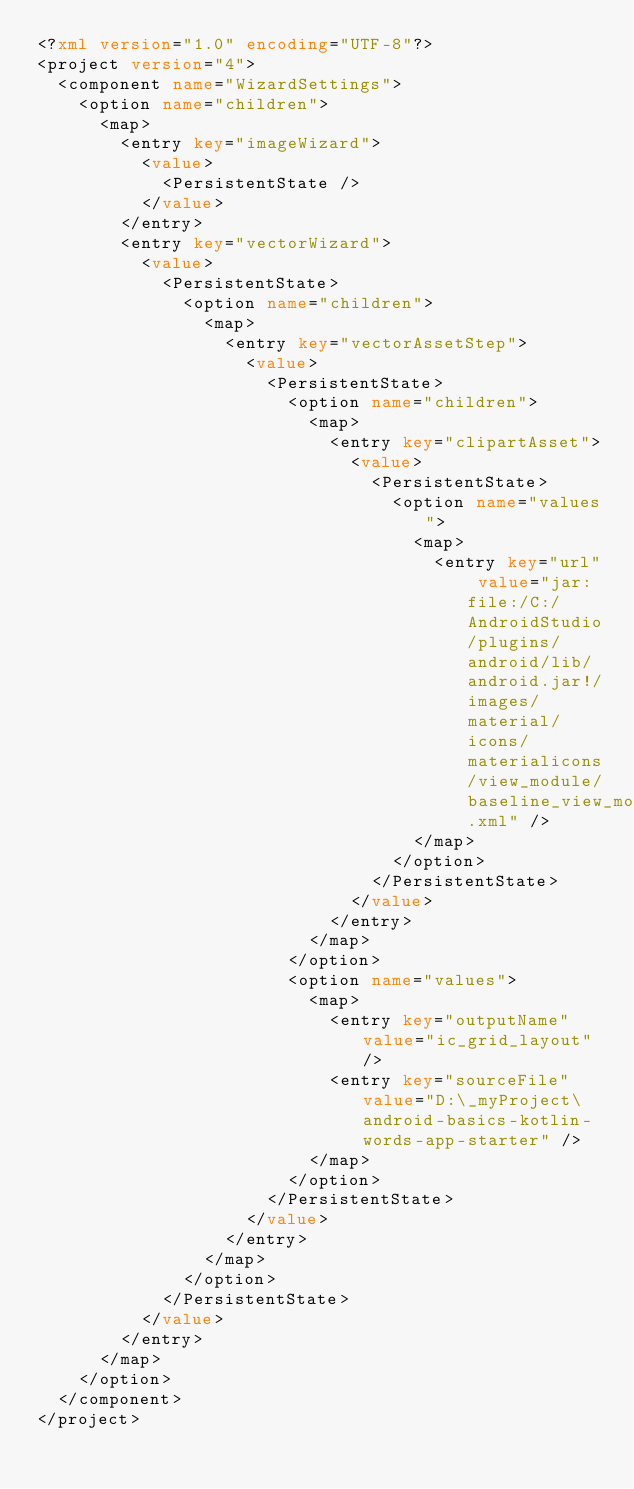Convert code to text. <code><loc_0><loc_0><loc_500><loc_500><_XML_><?xml version="1.0" encoding="UTF-8"?>
<project version="4">
  <component name="WizardSettings">
    <option name="children">
      <map>
        <entry key="imageWizard">
          <value>
            <PersistentState />
          </value>
        </entry>
        <entry key="vectorWizard">
          <value>
            <PersistentState>
              <option name="children">
                <map>
                  <entry key="vectorAssetStep">
                    <value>
                      <PersistentState>
                        <option name="children">
                          <map>
                            <entry key="clipartAsset">
                              <value>
                                <PersistentState>
                                  <option name="values">
                                    <map>
                                      <entry key="url" value="jar:file:/C:/AndroidStudio/plugins/android/lib/android.jar!/images/material/icons/materialicons/view_module/baseline_view_module_24.xml" />
                                    </map>
                                  </option>
                                </PersistentState>
                              </value>
                            </entry>
                          </map>
                        </option>
                        <option name="values">
                          <map>
                            <entry key="outputName" value="ic_grid_layout" />
                            <entry key="sourceFile" value="D:\_myProject\android-basics-kotlin-words-app-starter" />
                          </map>
                        </option>
                      </PersistentState>
                    </value>
                  </entry>
                </map>
              </option>
            </PersistentState>
          </value>
        </entry>
      </map>
    </option>
  </component>
</project></code> 